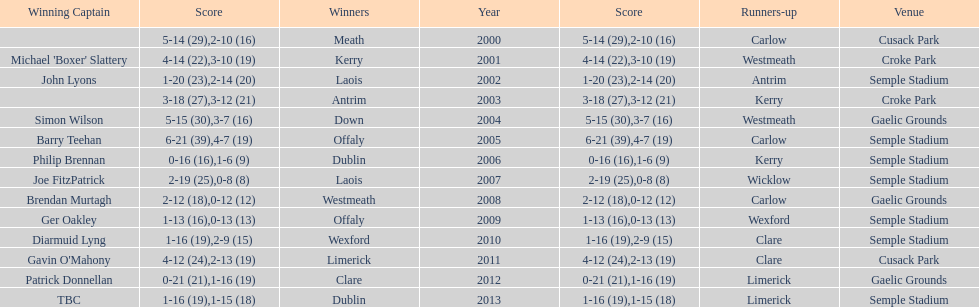Which team was the previous winner before dublin in 2013? Clare. 